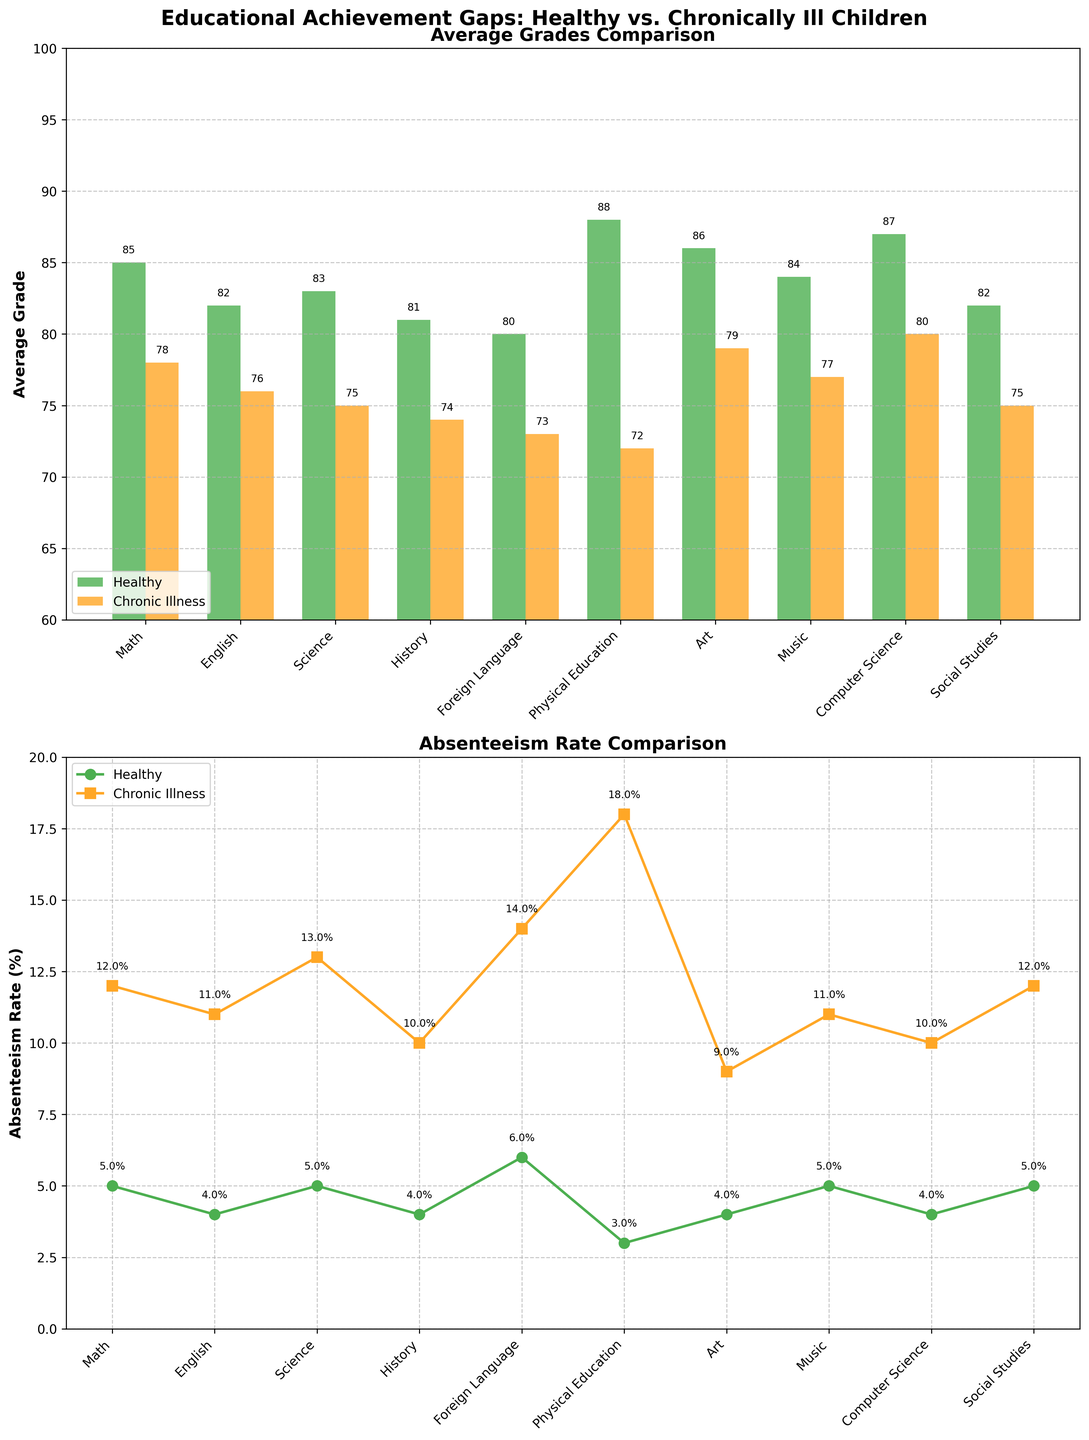How is the average grade in Physical Education for healthy children compared to those with chronic illnesses? The bar labeled "Physical Education" in the Average Grades Comparison subplot shows the green bar (healthy) is at 88 and the orange bar (chronic illness) is at 72. Thus, healthy children have an average grade of 88, and children with chronic illnesses have an average grade of 72.
Answer: 88 vs 72 Which subject has the highest absenteeism rate for children with chronic illnesses? According to the Absenteeism Rate Comparison subplot, the line indicating chronic absenteeism rates (orange) peaks at Physical Education with a rate of 18%.
Answer: Physical Education What is the difference between the average grade in Science for healthy children and those with chronic illnesses? The bar labeled "Science" in the Average Grades Comparison subplot shows 83 for healthy children and 75 for those with chronic illnesses. The difference is 83 - 75, which is 8.
Answer: 8 Compare the absenteeism rates for healthy children and those with chronic illnesses in Foreign Language. The Absenteeism Rate Comparison subplot indicates that for Foreign Language, the green line (healthy) is at 6% and the orange line (chronic illness) is at 14%.
Answer: 6% vs 14% In which subject is the gap in average grade between healthy children and those with chronic illnesses the smallest? By inspecting the Average Grades Comparison subplot, the smallest difference appears to be in Computer Science, where healthy children have an average grade of 87, and those with chronic illnesses have an average grade of 80. The gap is 7.
Answer: Computer Science How does the absenteeism rate for healthy children in Math compare to English? In the Absenteeism Rate Comparison subplot, the absenteeism rate for healthy children in Math is 5%, while for English, it is 4%.
Answer: 5% vs 4% What is the total average grade for children with chronic illnesses across all subjects? Adding up the grades for children with chronic illnesses from the Average Grades Comparison subplot: 78 + 76 + 75 + 74 + 73 + 72 + 79 + 77 + 80 + 75 = 759
Answer: 759 How much higher is the absenteeism rate for children with chronic illnesses compared to healthy children in Science? The Absenteeism Rate Comparison subplot shows that in Science, the rate is 13% for children with chronic illnesses and 5% for healthy children. The difference is 13% - 5% = 8%
Answer: 8% Identify the subject with the lowest average grade for chronically ill children. According to the Average Grades Comparison subplot, the subject with the lowest average grade for chronically ill children is Physical Education with a grade of 72.
Answer: Physical Education In which subject do healthy children have the highest average grade? From the Average Grades Comparison subplot, the highest average grade for healthy children is in Physical Education with a grade of 88.
Answer: Physical Education 